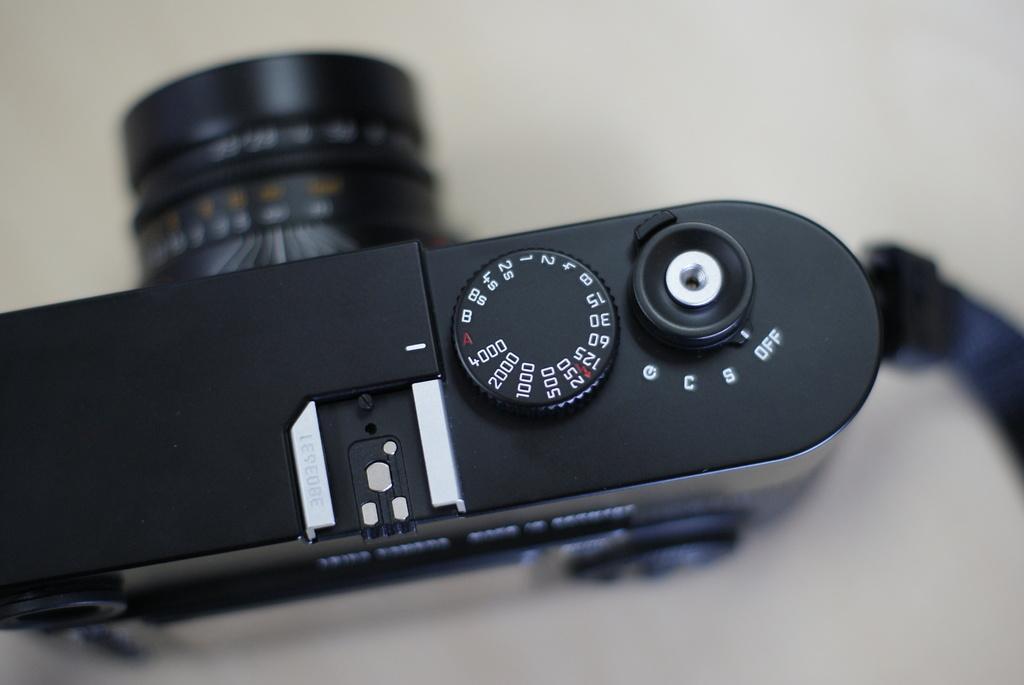How would you summarize this image in a sentence or two? In this image I can see a black color camera. 